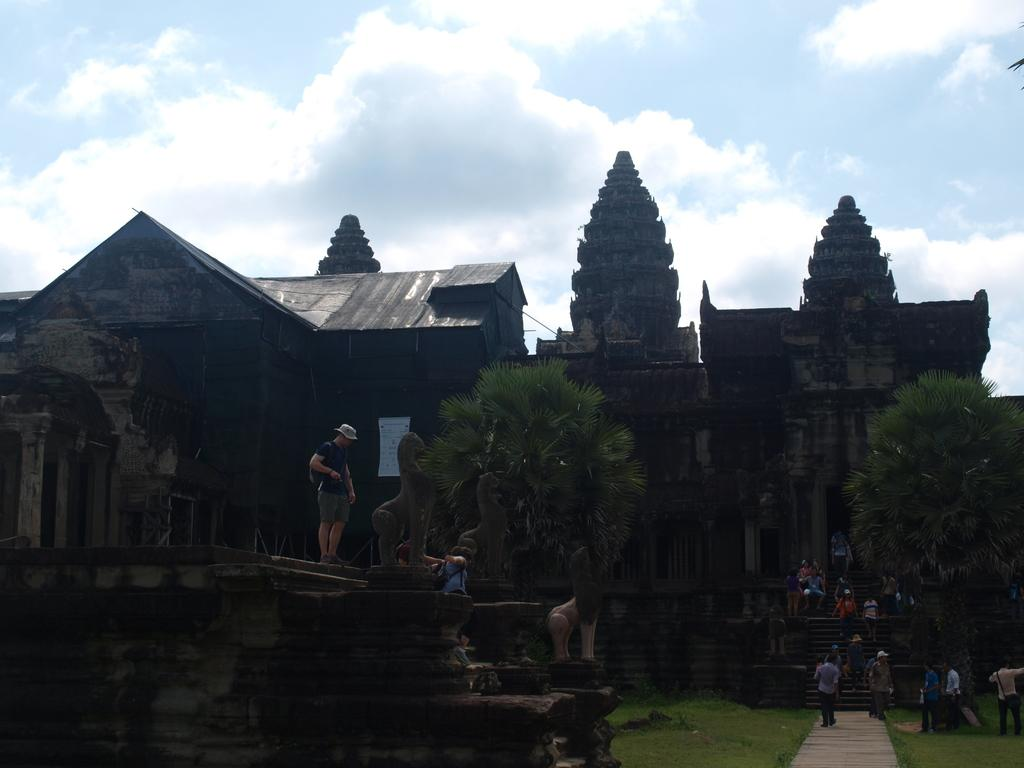What type of natural elements can be seen in the image? There are trees in the image. What type of man-made structures are present in the image? There are buildings in the image. What celestial objects can be seen in the image? Stars are visible in the image. What activity are the people in the image engaged in? There are people walking in the image. What is the weather like in the image? The sky is cloudy in the image. How many pets are visible in the image? There are no pets present in the image. What is the position of the girls in the image? There is no mention of girls in the image, so we cannot determine their position. 